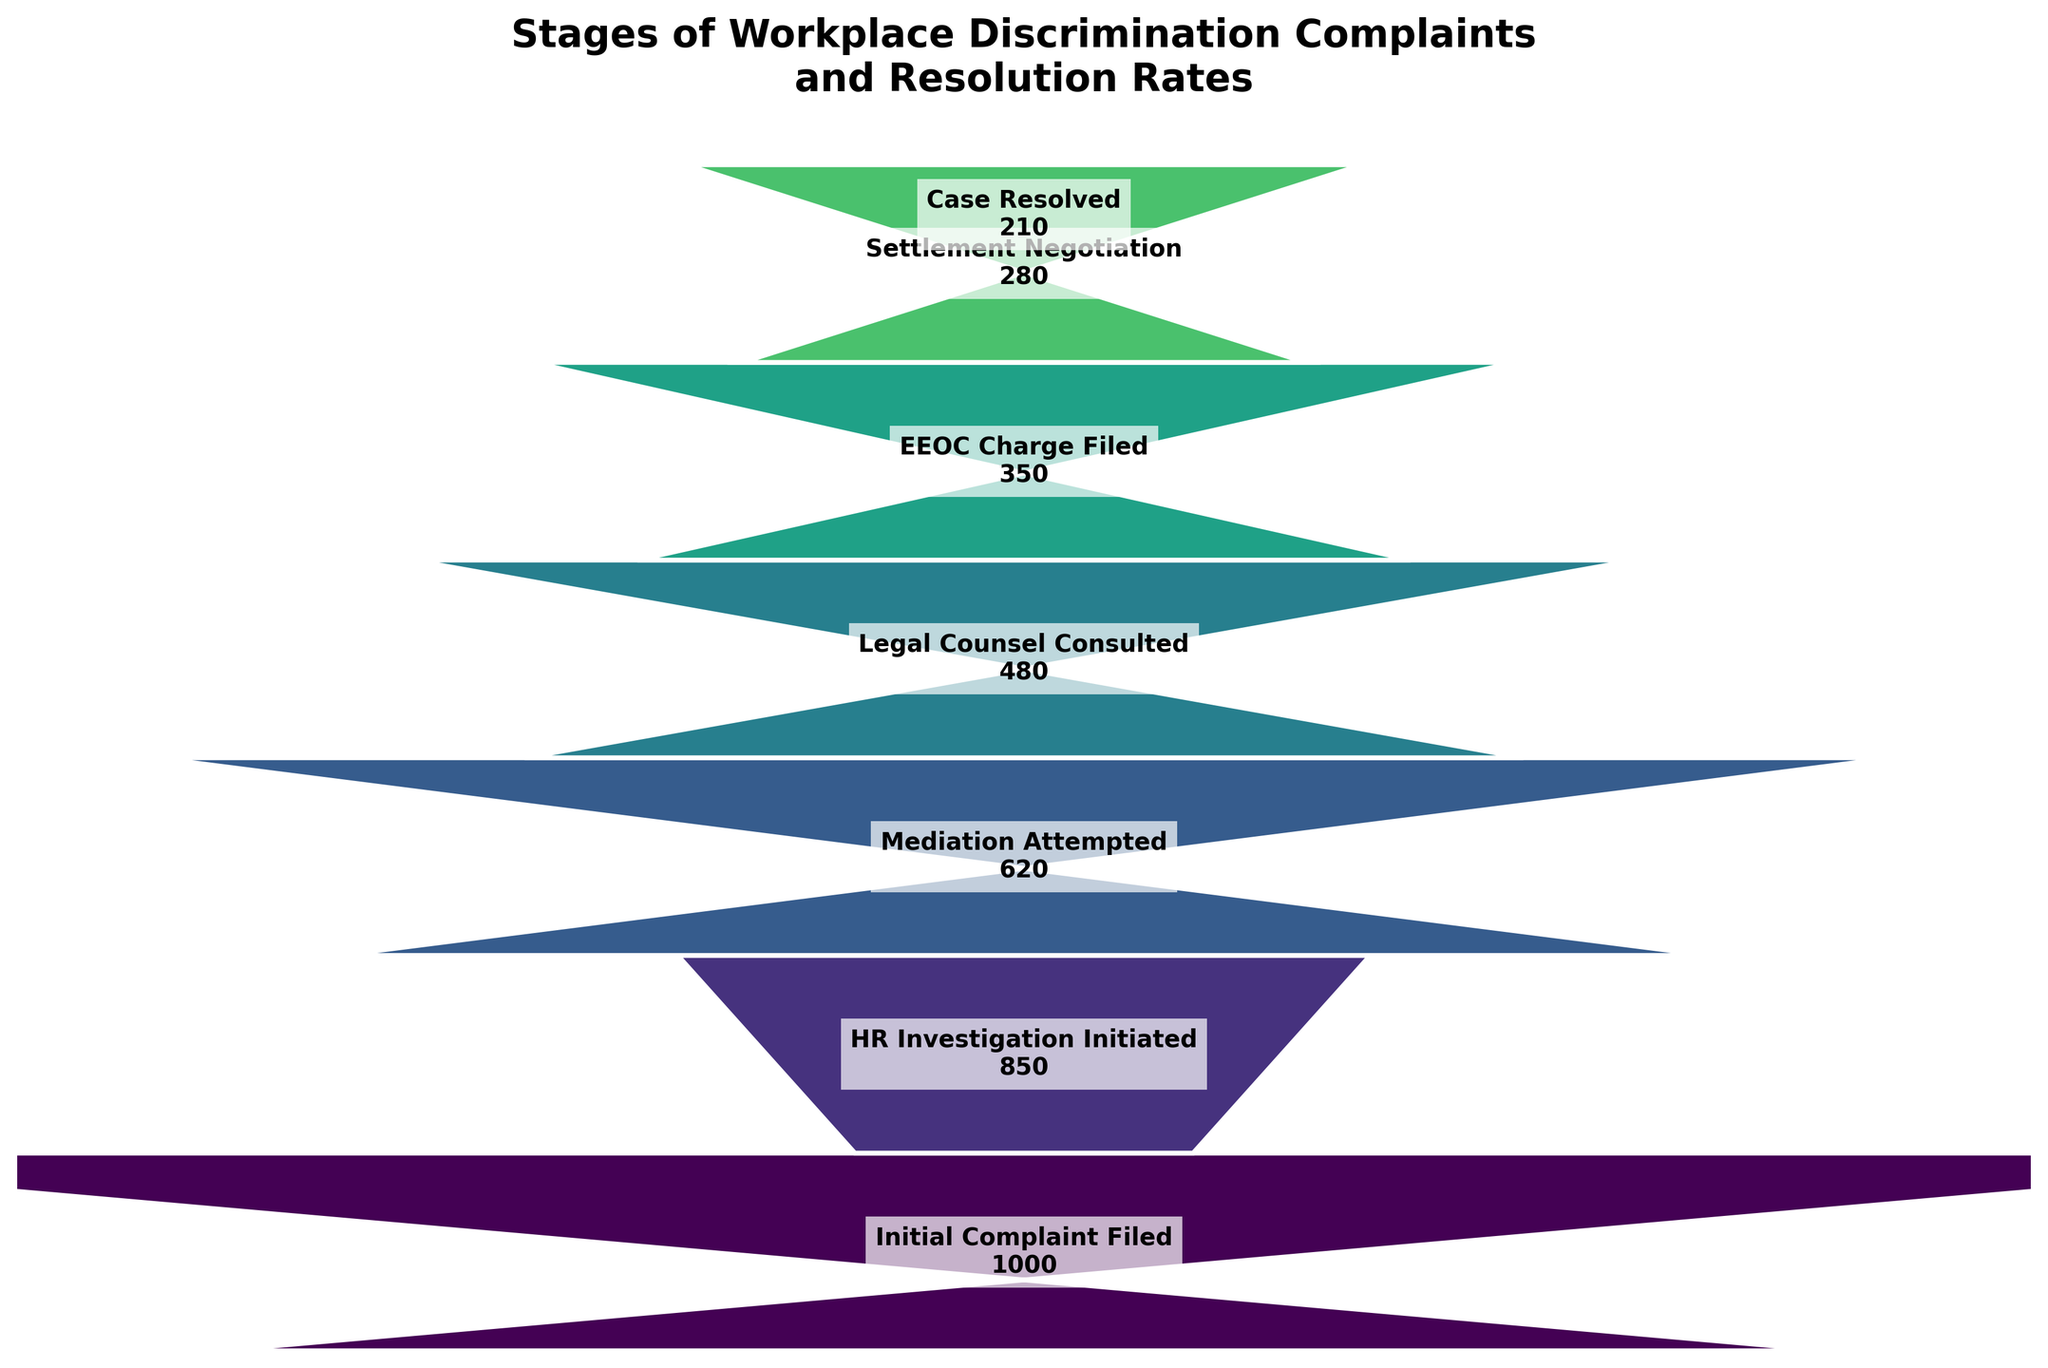What is the title of the funnel chart? The title is located at the top of the chart and reads "Stages of Workplace Discrimination Complaints and Resolution Rates" in bold, large font.
Answer: Stages of Workplace Discrimination Complaints and Resolution Rates How many cases were filed with the EEOC? The funnel chart shows the number of cases at each stage, and for the EEOC Charge Filed stage, it lists exactly 350 cases.
Answer: 350 At which stage is the number of cases reduced to 210? By looking at the funnel chart, we can see that the stage where the number of cases is 210 is the Case Resolved stage, which is the final stage of the funnel.
Answer: Case Resolved What's the difference in the number of cases between Mediation Attempted and Settlement Negotiation stages? We subtract the number of cases in the Settlement Negotiation stage (280) from the number of cases in the Mediation Attempted stage (620), resulting in 620 - 280 = 340.
Answer: 340 How many stages are there in the funnel chart? By counting the stages listed in the funnel chart, we can see there are seven stages from Initial Complaint Filed to Case Resolved.
Answer: 7 How many cases do not reach the HR Investigation Initiated stage? Subtract the number of cases in the HR Investigation Initiated stage (850) from the Initial Complaint Filed stage (1000), resulting in 1000 - 850 = 150 cases that do not reach HR Investigation Initiated.
Answer: 150 Which stage has the largest drop in the number of cases? By comparing the differences between successive stages, the largest drop in the number of cases occurs between Mediation Attempted (620) and Legal Counsel Consulted (480), a drop of 620 - 480 = 140 cases.
Answer: Mediation Attempted to Legal Counsel Consulted What percentage of initial complaints reach the stage of Settlement Negotiation? Divide the number of cases in the Settlement Negotiation stage (280) by the number of initial complaints filed (1000), and then multiply by 100 to convert to a percentage: (280 / 1000) * 100 = 28%.
Answer: 28% What proportion of cases are resolved by the end of the process? Divide the number of cases resolved (210) by the initial number of complaints filed (1000), and then convert to a percentage: (210 / 1000) * 100 = 21%.
Answer: 21% Which stage follows after mediation is attempted, according to the funnel chart? Directly following Mediation Attempted (620 cases), the next stage is Legal Counsel Consulted with 480 cases, according to the sequential order shown in the funnel chart.
Answer: Legal Counsel Consulted 